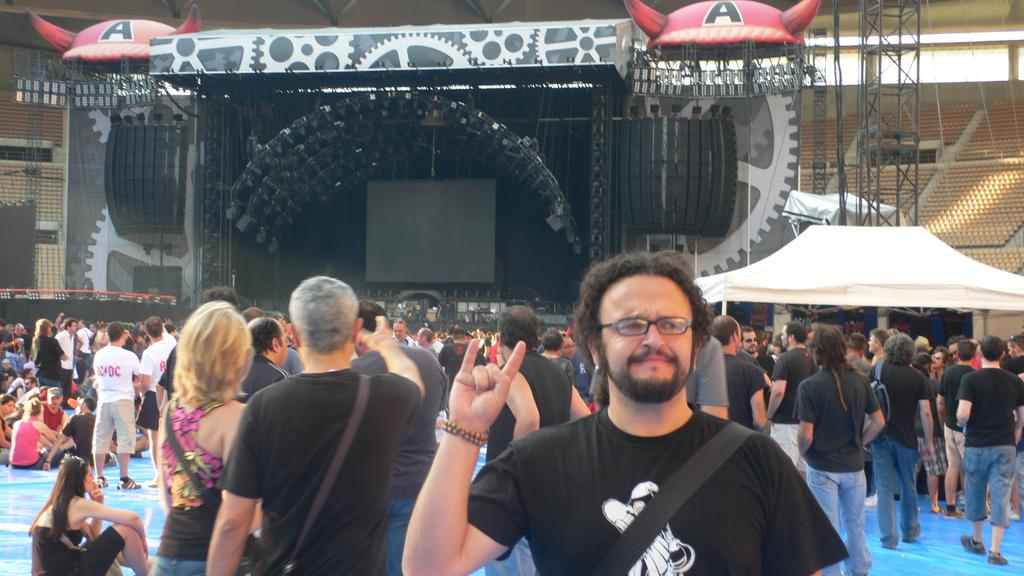What can be seen in the background of the image? There are people standing in front of the stage. What is present on the stage? There are focus lights on the stage. Can you tell me which actor is holding the paper on the stage? There is no actor or paper present on the stage in the image. What type of crime is being committed on the stage? There is no crime being committed on the stage in the image. 